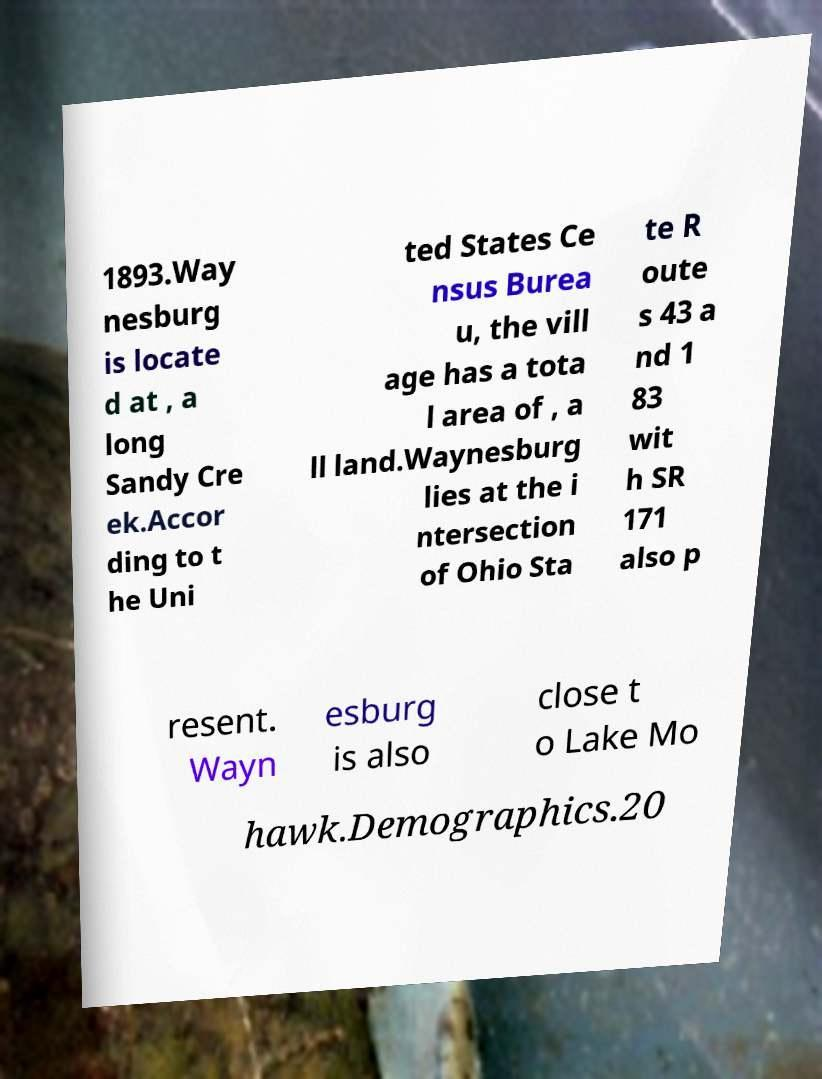What messages or text are displayed in this image? I need them in a readable, typed format. 1893.Way nesburg is locate d at , a long Sandy Cre ek.Accor ding to t he Uni ted States Ce nsus Burea u, the vill age has a tota l area of , a ll land.Waynesburg lies at the i ntersection of Ohio Sta te R oute s 43 a nd 1 83 wit h SR 171 also p resent. Wayn esburg is also close t o Lake Mo hawk.Demographics.20 